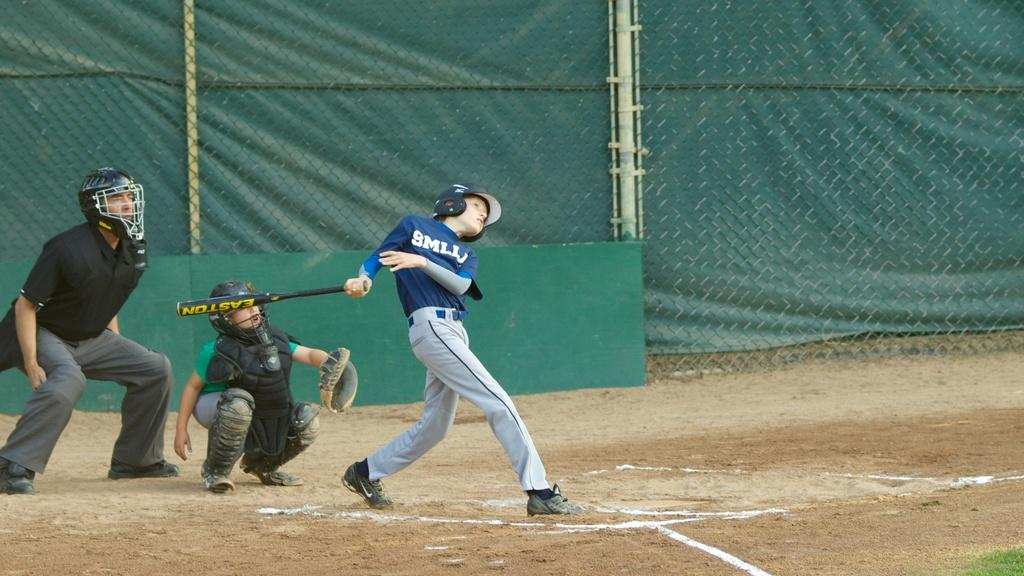<image>
Describe the image concisely. A young baseball player has just hit the ball with his Easton bat. 